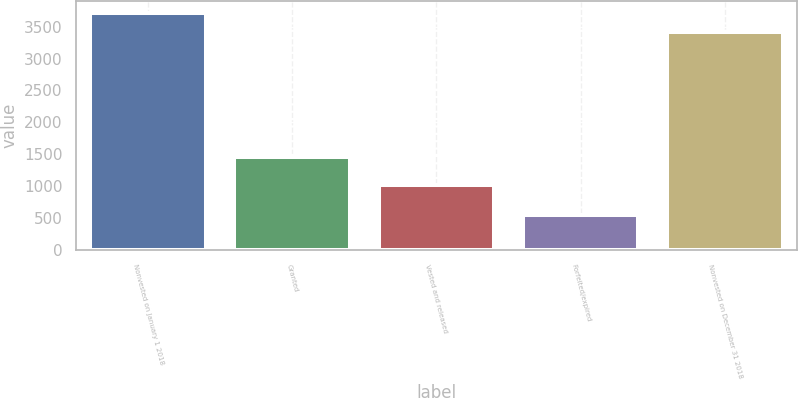Convert chart to OTSL. <chart><loc_0><loc_0><loc_500><loc_500><bar_chart><fcel>Nonvested on January 1 2018<fcel>Granted<fcel>Vested and released<fcel>Forfeited/expired<fcel>Nonvested on December 31 2018<nl><fcel>3720<fcel>1457<fcel>1015<fcel>555<fcel>3422<nl></chart> 